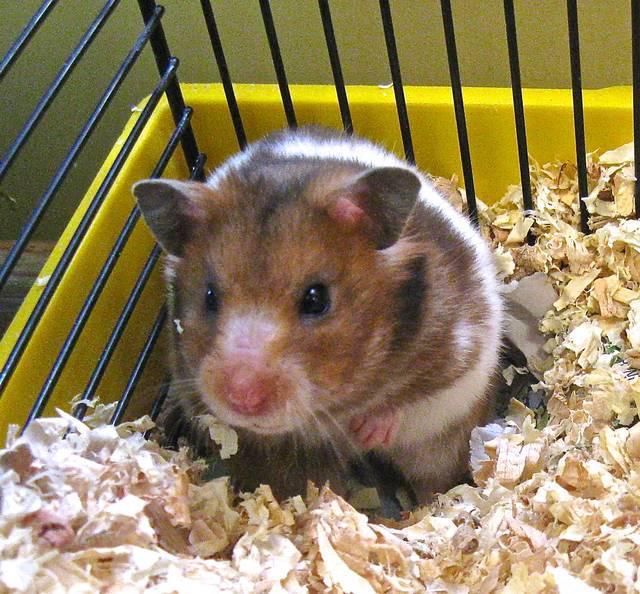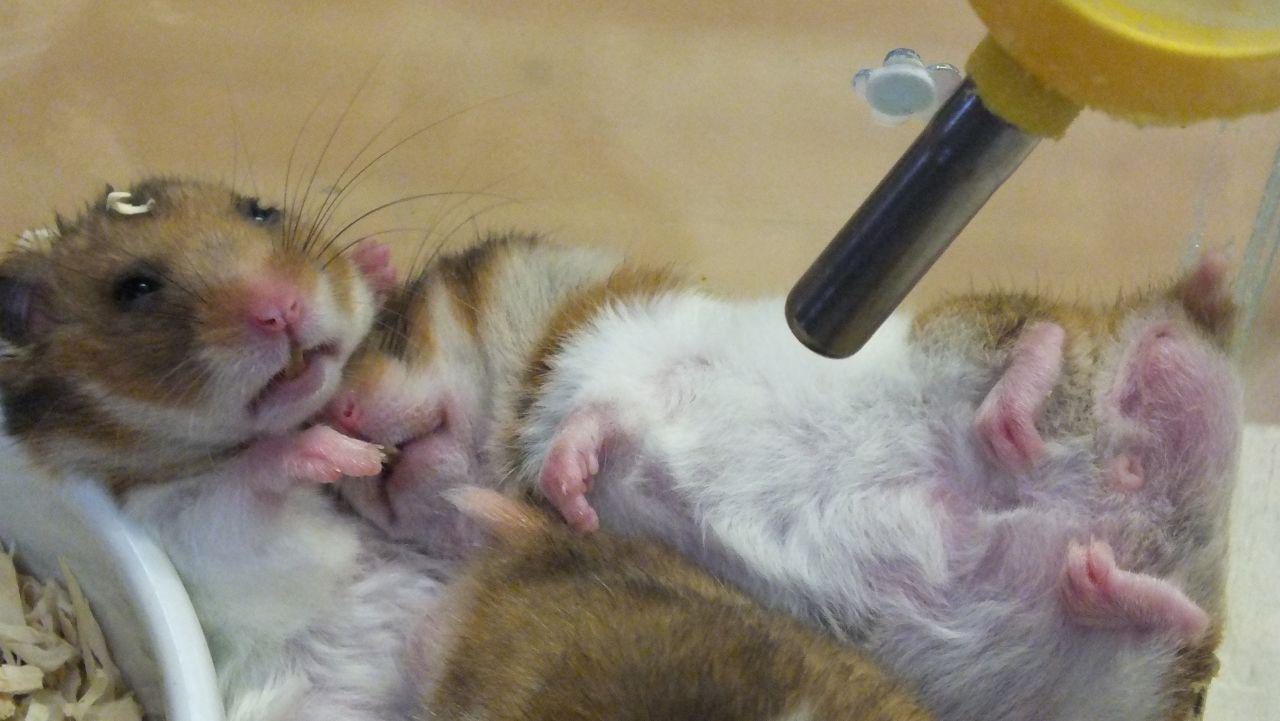The first image is the image on the left, the second image is the image on the right. Examine the images to the left and right. Is the description "An image includes a furry orange-and-white guinea pig near a smaller, shorter-haired rodent." accurate? Answer yes or no. No. The first image is the image on the left, the second image is the image on the right. Analyze the images presented: Is the assertion "The hamster in one of the images is in a wire cage." valid? Answer yes or no. Yes. 